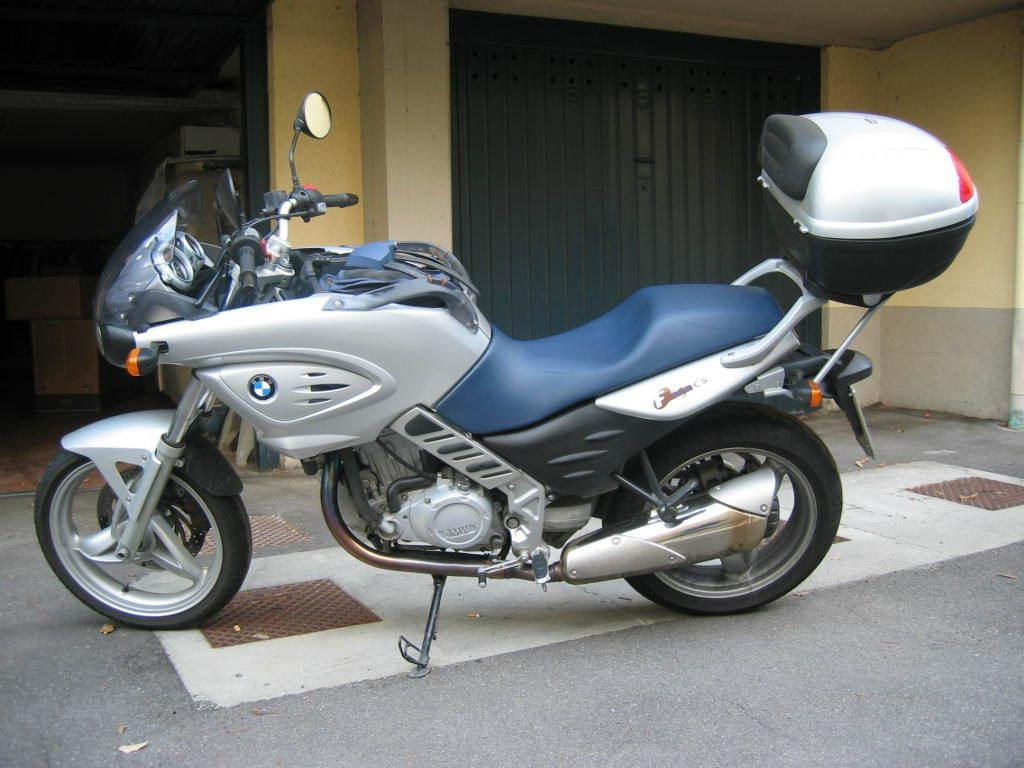What is the main subject of the image? The main subject of the image is a motorcycle. How is the motorcycle positioned in the image? The motorcycle is placed on the ground. What can be seen in the background of the image? There is a door visible in the background of the image. What color is the light illuminating the motorcycle in the image? There is no light visible in the image, so it cannot be determined what color it might be. 